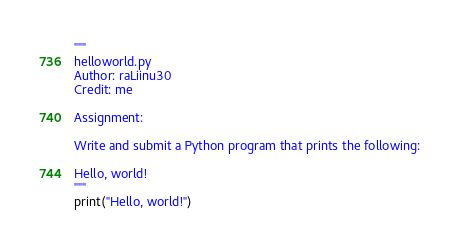<code> <loc_0><loc_0><loc_500><loc_500><_Python_>"""
helloworld.py
Author: raLiinu30
Credit: me

Assignment:

Write and submit a Python program that prints the following:

Hello, world!
"""
print("Hello, world!")
</code> 